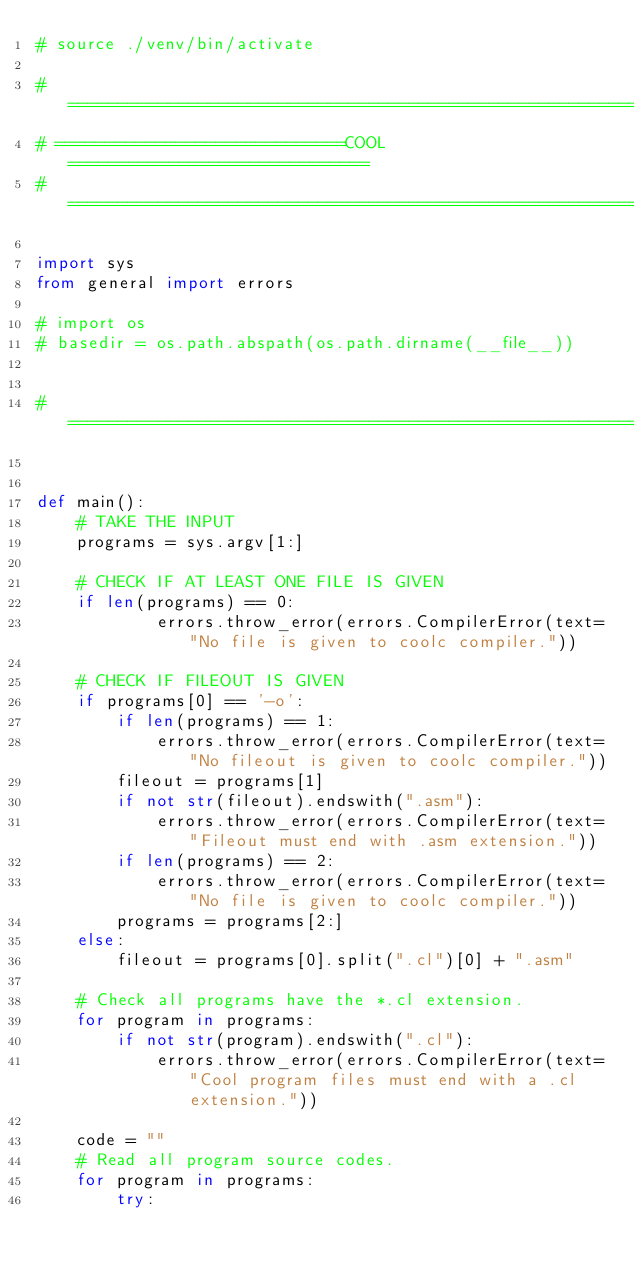<code> <loc_0><loc_0><loc_500><loc_500><_Python_># source ./venv/bin/activate

# ===============================================================
# =============================COOL==============================
# ===============================================================

import sys
from general import errors

# import os
# basedir = os.path.abspath(os.path.dirname(__file__))


# ===============================================================


def main():
    # TAKE THE INPUT
    programs = sys.argv[1:]

    # CHECK IF AT LEAST ONE FILE IS GIVEN
    if len(programs) == 0:
            errors.throw_error(errors.CompilerError(text="No file is given to coolc compiler."))

    # CHECK IF FILEOUT IS GIVEN
    if programs[0] == '-o':
        if len(programs) == 1:
            errors.throw_error(errors.CompilerError(text="No fileout is given to coolc compiler."))
        fileout = programs[1]
        if not str(fileout).endswith(".asm"):
            errors.throw_error(errors.CompilerError(text="Fileout must end with .asm extension."))
        if len(programs) == 2:
            errors.throw_error(errors.CompilerError(text="No file is given to coolc compiler."))
        programs = programs[2:]
    else:
        fileout = programs[0].split(".cl")[0] + ".asm"

    # Check all programs have the *.cl extension.
    for program in programs:
        if not str(program).endswith(".cl"):
            errors.throw_error(errors.CompilerError(text="Cool program files must end with a .cl extension."))
    
    code = ""
    # Read all program source codes.
    for program in programs:
        try:</code> 